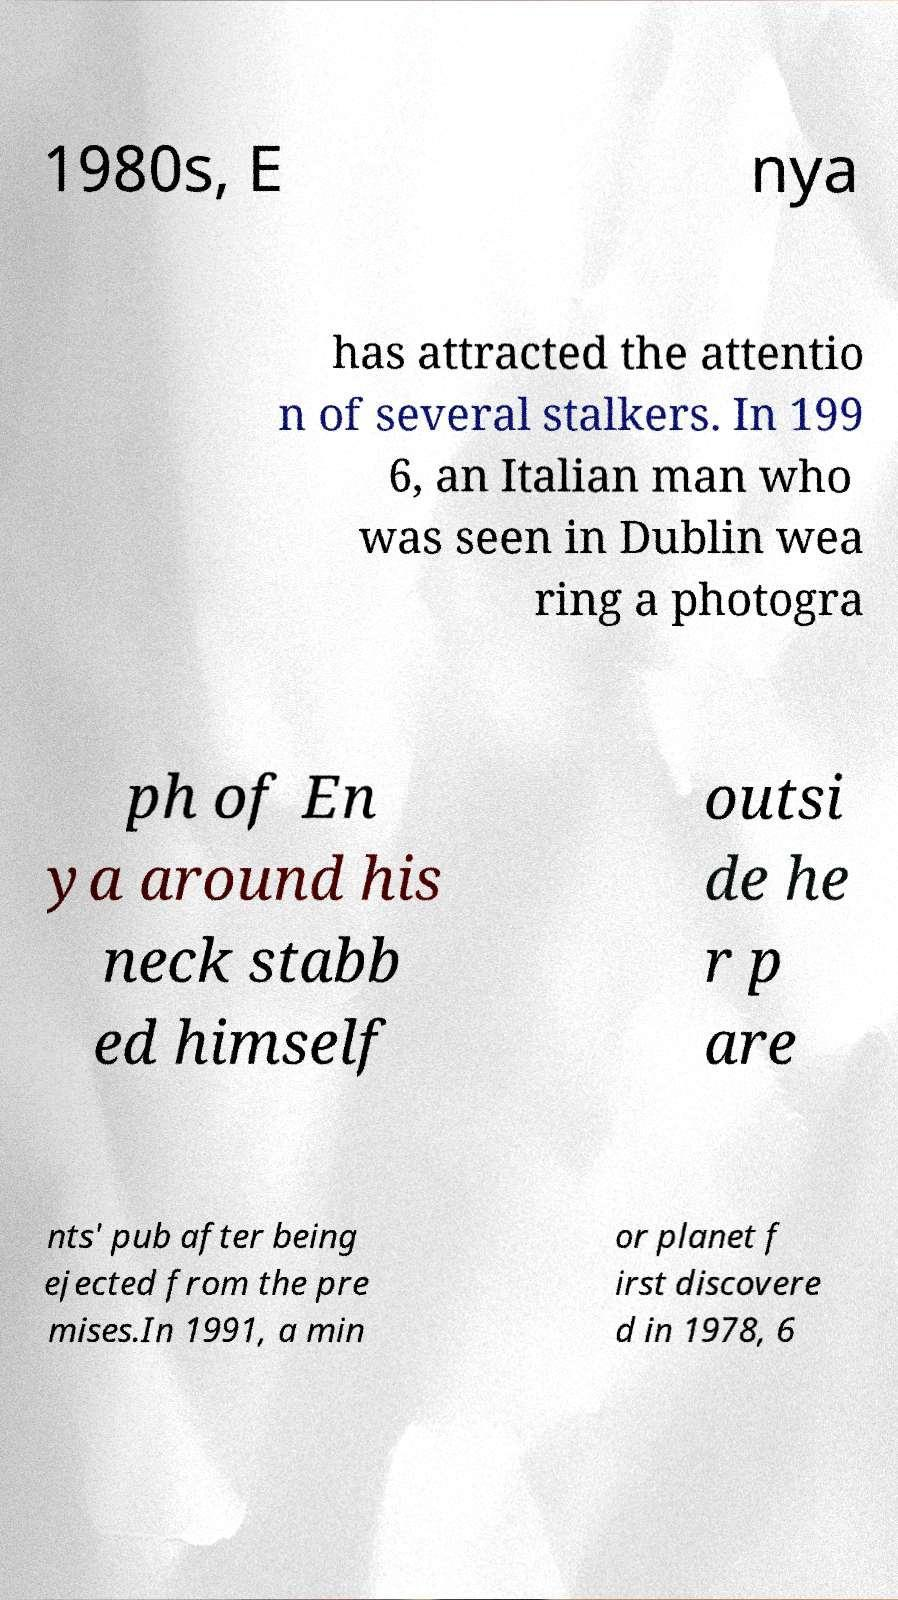Could you extract and type out the text from this image? 1980s, E nya has attracted the attentio n of several stalkers. In 199 6, an Italian man who was seen in Dublin wea ring a photogra ph of En ya around his neck stabb ed himself outsi de he r p are nts' pub after being ejected from the pre mises.In 1991, a min or planet f irst discovere d in 1978, 6 